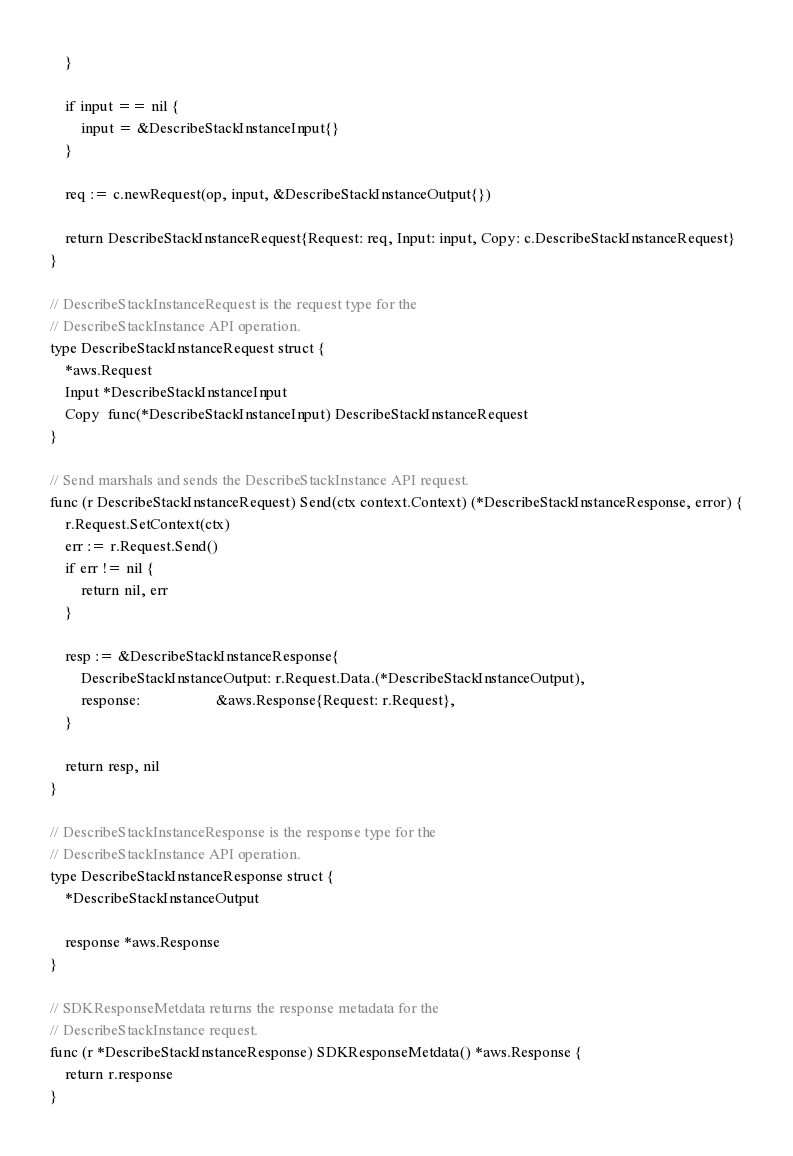<code> <loc_0><loc_0><loc_500><loc_500><_Go_>	}

	if input == nil {
		input = &DescribeStackInstanceInput{}
	}

	req := c.newRequest(op, input, &DescribeStackInstanceOutput{})

	return DescribeStackInstanceRequest{Request: req, Input: input, Copy: c.DescribeStackInstanceRequest}
}

// DescribeStackInstanceRequest is the request type for the
// DescribeStackInstance API operation.
type DescribeStackInstanceRequest struct {
	*aws.Request
	Input *DescribeStackInstanceInput
	Copy  func(*DescribeStackInstanceInput) DescribeStackInstanceRequest
}

// Send marshals and sends the DescribeStackInstance API request.
func (r DescribeStackInstanceRequest) Send(ctx context.Context) (*DescribeStackInstanceResponse, error) {
	r.Request.SetContext(ctx)
	err := r.Request.Send()
	if err != nil {
		return nil, err
	}

	resp := &DescribeStackInstanceResponse{
		DescribeStackInstanceOutput: r.Request.Data.(*DescribeStackInstanceOutput),
		response:                    &aws.Response{Request: r.Request},
	}

	return resp, nil
}

// DescribeStackInstanceResponse is the response type for the
// DescribeStackInstance API operation.
type DescribeStackInstanceResponse struct {
	*DescribeStackInstanceOutput

	response *aws.Response
}

// SDKResponseMetdata returns the response metadata for the
// DescribeStackInstance request.
func (r *DescribeStackInstanceResponse) SDKResponseMetdata() *aws.Response {
	return r.response
}
</code> 